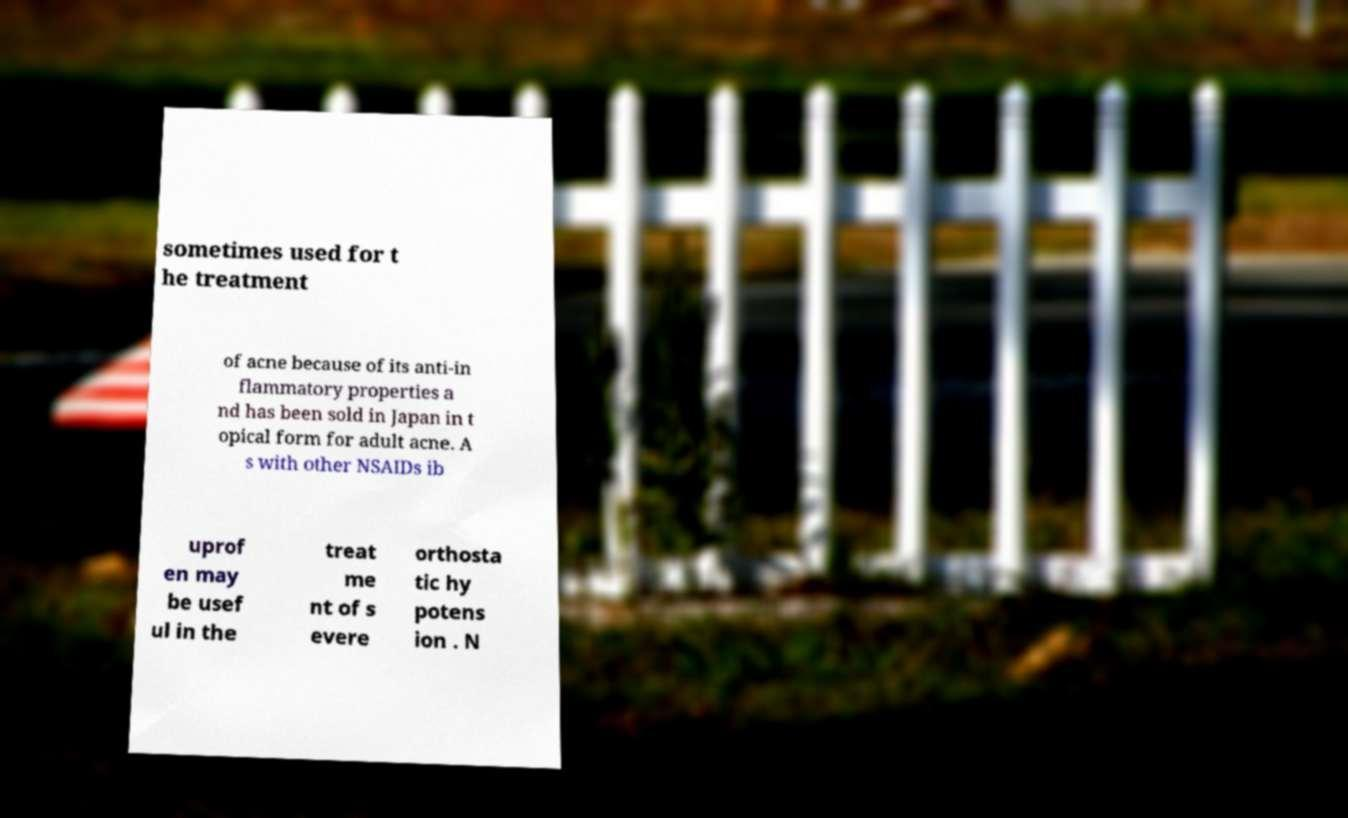Can you read and provide the text displayed in the image?This photo seems to have some interesting text. Can you extract and type it out for me? sometimes used for t he treatment of acne because of its anti-in flammatory properties a nd has been sold in Japan in t opical form for adult acne. A s with other NSAIDs ib uprof en may be usef ul in the treat me nt of s evere orthosta tic hy potens ion . N 